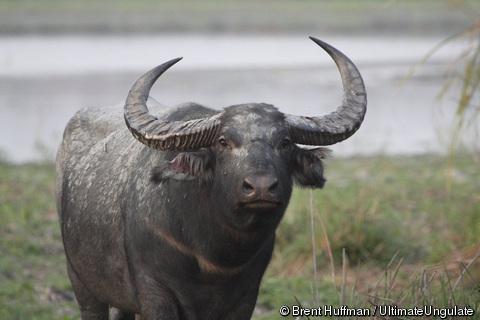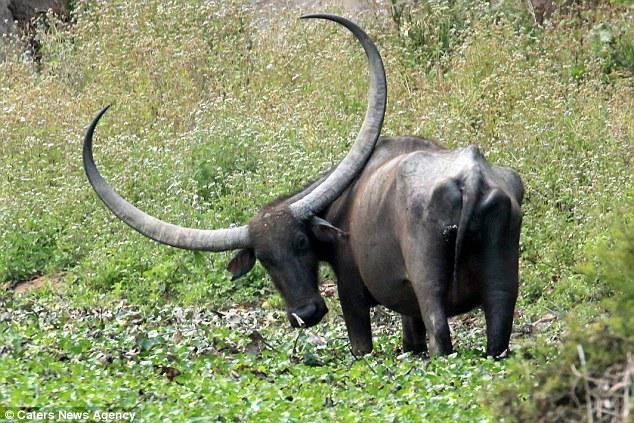The first image is the image on the left, the second image is the image on the right. Assess this claim about the two images: "In at least one of the images, a single water buffalo is standing in deep water.". Correct or not? Answer yes or no. No. The first image is the image on the left, the second image is the image on the right. Given the left and right images, does the statement "An image contains a water buffalo partially under water." hold true? Answer yes or no. No. 